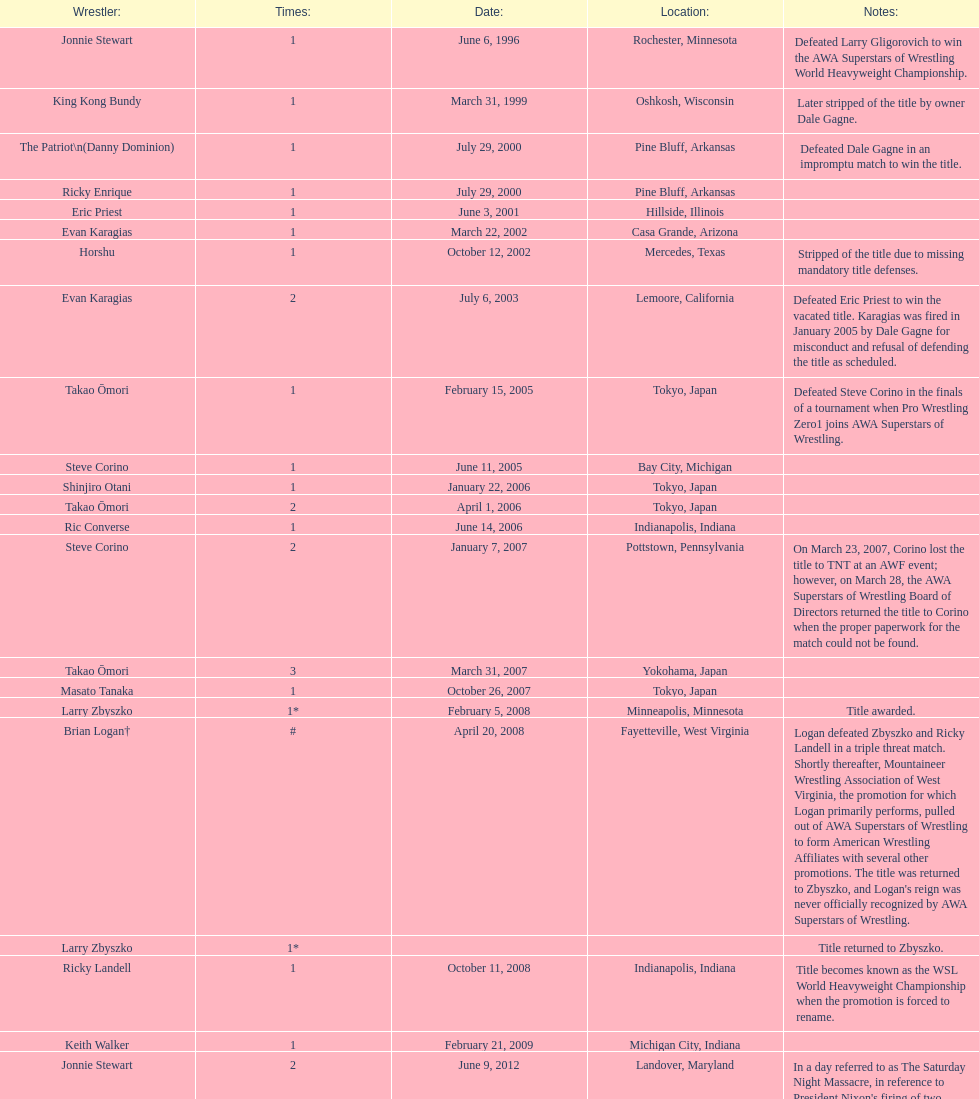Can you parse all the data within this table? {'header': ['Wrestler:', 'Times:', 'Date:', 'Location:', 'Notes:'], 'rows': [['Jonnie Stewart', '1', 'June 6, 1996', 'Rochester, Minnesota', 'Defeated Larry Gligorovich to win the AWA Superstars of Wrestling World Heavyweight Championship.'], ['King Kong Bundy', '1', 'March 31, 1999', 'Oshkosh, Wisconsin', 'Later stripped of the title by owner Dale Gagne.'], ['The Patriot\\n(Danny Dominion)', '1', 'July 29, 2000', 'Pine Bluff, Arkansas', 'Defeated Dale Gagne in an impromptu match to win the title.'], ['Ricky Enrique', '1', 'July 29, 2000', 'Pine Bluff, Arkansas', ''], ['Eric Priest', '1', 'June 3, 2001', 'Hillside, Illinois', ''], ['Evan Karagias', '1', 'March 22, 2002', 'Casa Grande, Arizona', ''], ['Horshu', '1', 'October 12, 2002', 'Mercedes, Texas', 'Stripped of the title due to missing mandatory title defenses.'], ['Evan Karagias', '2', 'July 6, 2003', 'Lemoore, California', 'Defeated Eric Priest to win the vacated title. Karagias was fired in January 2005 by Dale Gagne for misconduct and refusal of defending the title as scheduled.'], ['Takao Ōmori', '1', 'February 15, 2005', 'Tokyo, Japan', 'Defeated Steve Corino in the finals of a tournament when Pro Wrestling Zero1 joins AWA Superstars of Wrestling.'], ['Steve Corino', '1', 'June 11, 2005', 'Bay City, Michigan', ''], ['Shinjiro Otani', '1', 'January 22, 2006', 'Tokyo, Japan', ''], ['Takao Ōmori', '2', 'April 1, 2006', 'Tokyo, Japan', ''], ['Ric Converse', '1', 'June 14, 2006', 'Indianapolis, Indiana', ''], ['Steve Corino', '2', 'January 7, 2007', 'Pottstown, Pennsylvania', 'On March 23, 2007, Corino lost the title to TNT at an AWF event; however, on March 28, the AWA Superstars of Wrestling Board of Directors returned the title to Corino when the proper paperwork for the match could not be found.'], ['Takao Ōmori', '3', 'March 31, 2007', 'Yokohama, Japan', ''], ['Masato Tanaka', '1', 'October 26, 2007', 'Tokyo, Japan', ''], ['Larry Zbyszko', '1*', 'February 5, 2008', 'Minneapolis, Minnesota', 'Title awarded.'], ['Brian Logan†', '#', 'April 20, 2008', 'Fayetteville, West Virginia', "Logan defeated Zbyszko and Ricky Landell in a triple threat match. Shortly thereafter, Mountaineer Wrestling Association of West Virginia, the promotion for which Logan primarily performs, pulled out of AWA Superstars of Wrestling to form American Wrestling Affiliates with several other promotions. The title was returned to Zbyszko, and Logan's reign was never officially recognized by AWA Superstars of Wrestling."], ['Larry Zbyszko', '1*', '', '', 'Title returned to Zbyszko.'], ['Ricky Landell', '1', 'October 11, 2008', 'Indianapolis, Indiana', 'Title becomes known as the WSL World Heavyweight Championship when the promotion is forced to rename.'], ['Keith Walker', '1', 'February 21, 2009', 'Michigan City, Indiana', ''], ['Jonnie Stewart', '2', 'June 9, 2012', 'Landover, Maryland', "In a day referred to as The Saturday Night Massacre, in reference to President Nixon's firing of two Whitehouse attorneys general in one night; President Dale Gagne strips and fires Keith Walker when Walker refuses to defend the title against Ricky Landell, in an event in Landover, Maryland. When Landell is awarded the title, he refuses to accept and is too promptly fired by Gagne, who than awards the title to Jonnie Stewart."], ['The Honky Tonk Man', '1', 'August 18, 2012', 'Rockford, Illinois', "The morning of the event, Jonnie Stewart's doctors declare him PUP (physically unable to perform) and WSL officials agree to let Mike Bally sub for Stewart."]]} The patriot (danny dominion) won the title from what previous holder through an impromptu match? Dale Gagne. 